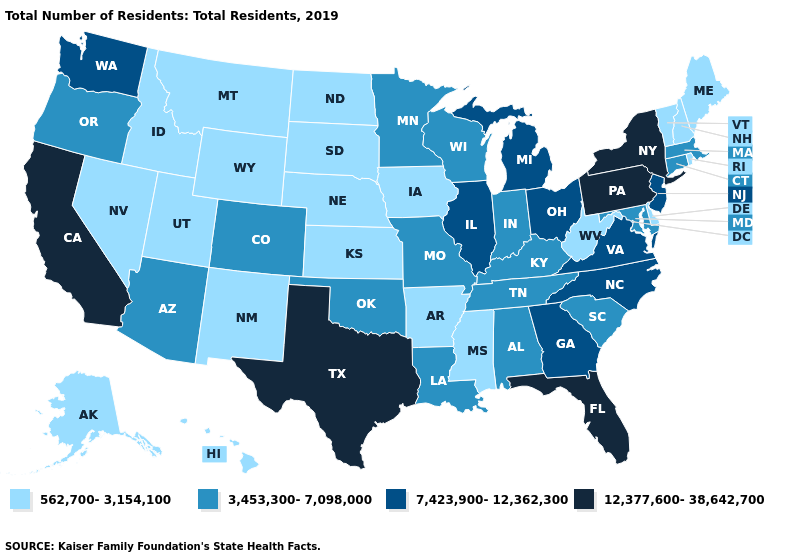What is the value of Michigan?
Concise answer only. 7,423,900-12,362,300. What is the value of Utah?
Answer briefly. 562,700-3,154,100. What is the value of Kansas?
Answer briefly. 562,700-3,154,100. What is the highest value in the USA?
Give a very brief answer. 12,377,600-38,642,700. How many symbols are there in the legend?
Quick response, please. 4. Among the states that border Oklahoma , which have the lowest value?
Give a very brief answer. Arkansas, Kansas, New Mexico. What is the value of Hawaii?
Give a very brief answer. 562,700-3,154,100. What is the highest value in states that border Georgia?
Keep it brief. 12,377,600-38,642,700. What is the value of South Dakota?
Write a very short answer. 562,700-3,154,100. Does Alaska have the lowest value in the USA?
Short answer required. Yes. Does Pennsylvania have the highest value in the USA?
Write a very short answer. Yes. Which states have the lowest value in the USA?
Keep it brief. Alaska, Arkansas, Delaware, Hawaii, Idaho, Iowa, Kansas, Maine, Mississippi, Montana, Nebraska, Nevada, New Hampshire, New Mexico, North Dakota, Rhode Island, South Dakota, Utah, Vermont, West Virginia, Wyoming. What is the value of Connecticut?
Be succinct. 3,453,300-7,098,000. Name the states that have a value in the range 3,453,300-7,098,000?
Concise answer only. Alabama, Arizona, Colorado, Connecticut, Indiana, Kentucky, Louisiana, Maryland, Massachusetts, Minnesota, Missouri, Oklahoma, Oregon, South Carolina, Tennessee, Wisconsin. Name the states that have a value in the range 12,377,600-38,642,700?
Answer briefly. California, Florida, New York, Pennsylvania, Texas. 